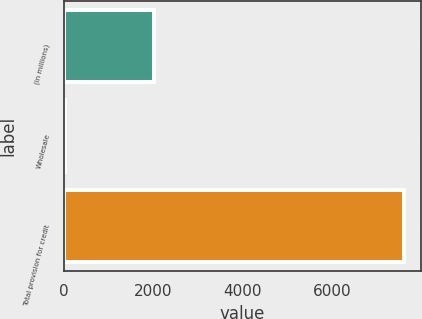<chart> <loc_0><loc_0><loc_500><loc_500><bar_chart><fcel>(in millions)<fcel>Wholesale<fcel>Total provision for credit<nl><fcel>2011<fcel>17<fcel>7612<nl></chart> 